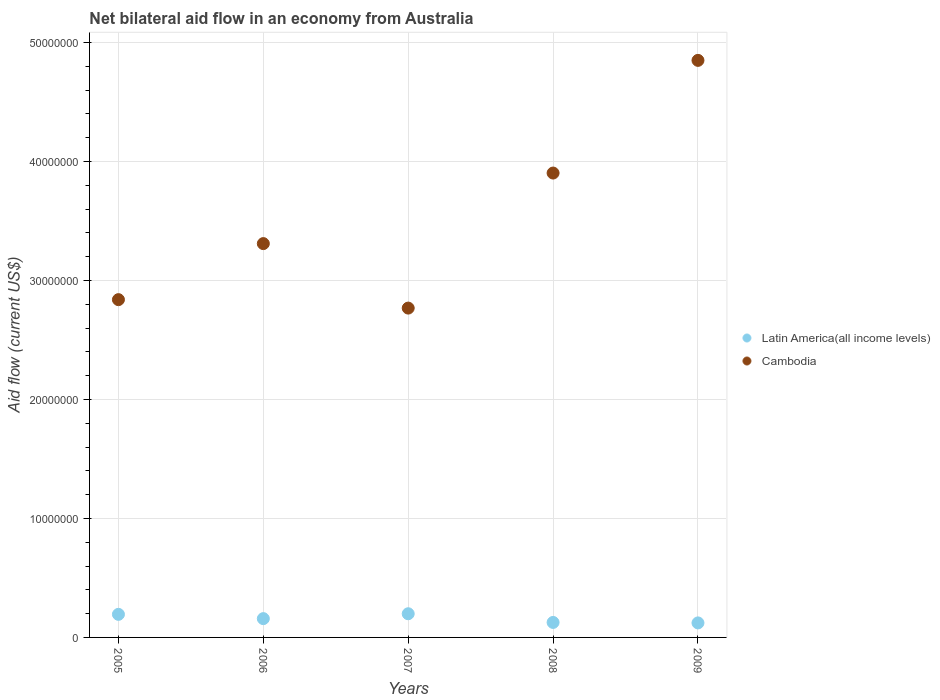What is the net bilateral aid flow in Cambodia in 2007?
Your response must be concise. 2.77e+07. Across all years, what is the maximum net bilateral aid flow in Cambodia?
Give a very brief answer. 4.85e+07. Across all years, what is the minimum net bilateral aid flow in Cambodia?
Provide a succinct answer. 2.77e+07. What is the total net bilateral aid flow in Cambodia in the graph?
Give a very brief answer. 1.77e+08. What is the difference between the net bilateral aid flow in Latin America(all income levels) in 2005 and that in 2006?
Offer a terse response. 3.60e+05. What is the difference between the net bilateral aid flow in Cambodia in 2006 and the net bilateral aid flow in Latin America(all income levels) in 2009?
Your answer should be very brief. 3.19e+07. What is the average net bilateral aid flow in Latin America(all income levels) per year?
Offer a very short reply. 1.60e+06. In the year 2009, what is the difference between the net bilateral aid flow in Latin America(all income levels) and net bilateral aid flow in Cambodia?
Provide a succinct answer. -4.73e+07. In how many years, is the net bilateral aid flow in Latin America(all income levels) greater than 2000000 US$?
Offer a very short reply. 0. What is the ratio of the net bilateral aid flow in Cambodia in 2006 to that in 2007?
Offer a terse response. 1.2. Is the net bilateral aid flow in Cambodia in 2005 less than that in 2009?
Give a very brief answer. Yes. What is the difference between the highest and the second highest net bilateral aid flow in Cambodia?
Offer a terse response. 9.47e+06. What is the difference between the highest and the lowest net bilateral aid flow in Cambodia?
Keep it short and to the point. 2.08e+07. In how many years, is the net bilateral aid flow in Latin America(all income levels) greater than the average net bilateral aid flow in Latin America(all income levels) taken over all years?
Your answer should be very brief. 2. Is the sum of the net bilateral aid flow in Latin America(all income levels) in 2006 and 2008 greater than the maximum net bilateral aid flow in Cambodia across all years?
Your response must be concise. No. Does the net bilateral aid flow in Cambodia monotonically increase over the years?
Give a very brief answer. No. How many dotlines are there?
Provide a succinct answer. 2. Are the values on the major ticks of Y-axis written in scientific E-notation?
Ensure brevity in your answer.  No. Where does the legend appear in the graph?
Ensure brevity in your answer.  Center right. How are the legend labels stacked?
Provide a succinct answer. Vertical. What is the title of the graph?
Offer a terse response. Net bilateral aid flow in an economy from Australia. What is the label or title of the X-axis?
Give a very brief answer. Years. What is the Aid flow (current US$) in Latin America(all income levels) in 2005?
Offer a very short reply. 1.94e+06. What is the Aid flow (current US$) of Cambodia in 2005?
Your answer should be very brief. 2.84e+07. What is the Aid flow (current US$) of Latin America(all income levels) in 2006?
Your response must be concise. 1.58e+06. What is the Aid flow (current US$) in Cambodia in 2006?
Provide a succinct answer. 3.31e+07. What is the Aid flow (current US$) of Latin America(all income levels) in 2007?
Provide a short and direct response. 1.99e+06. What is the Aid flow (current US$) in Cambodia in 2007?
Keep it short and to the point. 2.77e+07. What is the Aid flow (current US$) in Latin America(all income levels) in 2008?
Your answer should be compact. 1.26e+06. What is the Aid flow (current US$) of Cambodia in 2008?
Offer a terse response. 3.90e+07. What is the Aid flow (current US$) of Latin America(all income levels) in 2009?
Provide a succinct answer. 1.22e+06. What is the Aid flow (current US$) of Cambodia in 2009?
Make the answer very short. 4.85e+07. Across all years, what is the maximum Aid flow (current US$) of Latin America(all income levels)?
Your answer should be compact. 1.99e+06. Across all years, what is the maximum Aid flow (current US$) in Cambodia?
Make the answer very short. 4.85e+07. Across all years, what is the minimum Aid flow (current US$) of Latin America(all income levels)?
Give a very brief answer. 1.22e+06. Across all years, what is the minimum Aid flow (current US$) in Cambodia?
Make the answer very short. 2.77e+07. What is the total Aid flow (current US$) of Latin America(all income levels) in the graph?
Provide a succinct answer. 7.99e+06. What is the total Aid flow (current US$) of Cambodia in the graph?
Offer a very short reply. 1.77e+08. What is the difference between the Aid flow (current US$) in Latin America(all income levels) in 2005 and that in 2006?
Your response must be concise. 3.60e+05. What is the difference between the Aid flow (current US$) in Cambodia in 2005 and that in 2006?
Offer a terse response. -4.71e+06. What is the difference between the Aid flow (current US$) in Cambodia in 2005 and that in 2007?
Your answer should be very brief. 7.10e+05. What is the difference between the Aid flow (current US$) of Latin America(all income levels) in 2005 and that in 2008?
Offer a very short reply. 6.80e+05. What is the difference between the Aid flow (current US$) in Cambodia in 2005 and that in 2008?
Make the answer very short. -1.06e+07. What is the difference between the Aid flow (current US$) of Latin America(all income levels) in 2005 and that in 2009?
Give a very brief answer. 7.20e+05. What is the difference between the Aid flow (current US$) of Cambodia in 2005 and that in 2009?
Ensure brevity in your answer.  -2.01e+07. What is the difference between the Aid flow (current US$) of Latin America(all income levels) in 2006 and that in 2007?
Your answer should be compact. -4.10e+05. What is the difference between the Aid flow (current US$) of Cambodia in 2006 and that in 2007?
Your answer should be very brief. 5.42e+06. What is the difference between the Aid flow (current US$) in Latin America(all income levels) in 2006 and that in 2008?
Provide a succinct answer. 3.20e+05. What is the difference between the Aid flow (current US$) in Cambodia in 2006 and that in 2008?
Make the answer very short. -5.93e+06. What is the difference between the Aid flow (current US$) in Cambodia in 2006 and that in 2009?
Provide a short and direct response. -1.54e+07. What is the difference between the Aid flow (current US$) of Latin America(all income levels) in 2007 and that in 2008?
Ensure brevity in your answer.  7.30e+05. What is the difference between the Aid flow (current US$) in Cambodia in 2007 and that in 2008?
Make the answer very short. -1.14e+07. What is the difference between the Aid flow (current US$) of Latin America(all income levels) in 2007 and that in 2009?
Provide a short and direct response. 7.70e+05. What is the difference between the Aid flow (current US$) in Cambodia in 2007 and that in 2009?
Your answer should be very brief. -2.08e+07. What is the difference between the Aid flow (current US$) in Cambodia in 2008 and that in 2009?
Provide a succinct answer. -9.47e+06. What is the difference between the Aid flow (current US$) of Latin America(all income levels) in 2005 and the Aid flow (current US$) of Cambodia in 2006?
Provide a succinct answer. -3.12e+07. What is the difference between the Aid flow (current US$) of Latin America(all income levels) in 2005 and the Aid flow (current US$) of Cambodia in 2007?
Offer a very short reply. -2.57e+07. What is the difference between the Aid flow (current US$) of Latin America(all income levels) in 2005 and the Aid flow (current US$) of Cambodia in 2008?
Provide a succinct answer. -3.71e+07. What is the difference between the Aid flow (current US$) of Latin America(all income levels) in 2005 and the Aid flow (current US$) of Cambodia in 2009?
Offer a very short reply. -4.66e+07. What is the difference between the Aid flow (current US$) in Latin America(all income levels) in 2006 and the Aid flow (current US$) in Cambodia in 2007?
Offer a very short reply. -2.61e+07. What is the difference between the Aid flow (current US$) of Latin America(all income levels) in 2006 and the Aid flow (current US$) of Cambodia in 2008?
Your answer should be compact. -3.74e+07. What is the difference between the Aid flow (current US$) of Latin America(all income levels) in 2006 and the Aid flow (current US$) of Cambodia in 2009?
Offer a terse response. -4.69e+07. What is the difference between the Aid flow (current US$) in Latin America(all income levels) in 2007 and the Aid flow (current US$) in Cambodia in 2008?
Your answer should be compact. -3.70e+07. What is the difference between the Aid flow (current US$) of Latin America(all income levels) in 2007 and the Aid flow (current US$) of Cambodia in 2009?
Give a very brief answer. -4.65e+07. What is the difference between the Aid flow (current US$) in Latin America(all income levels) in 2008 and the Aid flow (current US$) in Cambodia in 2009?
Give a very brief answer. -4.72e+07. What is the average Aid flow (current US$) of Latin America(all income levels) per year?
Ensure brevity in your answer.  1.60e+06. What is the average Aid flow (current US$) in Cambodia per year?
Offer a very short reply. 3.53e+07. In the year 2005, what is the difference between the Aid flow (current US$) of Latin America(all income levels) and Aid flow (current US$) of Cambodia?
Give a very brief answer. -2.64e+07. In the year 2006, what is the difference between the Aid flow (current US$) in Latin America(all income levels) and Aid flow (current US$) in Cambodia?
Your answer should be compact. -3.15e+07. In the year 2007, what is the difference between the Aid flow (current US$) in Latin America(all income levels) and Aid flow (current US$) in Cambodia?
Give a very brief answer. -2.57e+07. In the year 2008, what is the difference between the Aid flow (current US$) in Latin America(all income levels) and Aid flow (current US$) in Cambodia?
Make the answer very short. -3.78e+07. In the year 2009, what is the difference between the Aid flow (current US$) in Latin America(all income levels) and Aid flow (current US$) in Cambodia?
Ensure brevity in your answer.  -4.73e+07. What is the ratio of the Aid flow (current US$) in Latin America(all income levels) in 2005 to that in 2006?
Provide a succinct answer. 1.23. What is the ratio of the Aid flow (current US$) in Cambodia in 2005 to that in 2006?
Offer a very short reply. 0.86. What is the ratio of the Aid flow (current US$) of Latin America(all income levels) in 2005 to that in 2007?
Provide a succinct answer. 0.97. What is the ratio of the Aid flow (current US$) of Cambodia in 2005 to that in 2007?
Your answer should be very brief. 1.03. What is the ratio of the Aid flow (current US$) of Latin America(all income levels) in 2005 to that in 2008?
Keep it short and to the point. 1.54. What is the ratio of the Aid flow (current US$) in Cambodia in 2005 to that in 2008?
Offer a very short reply. 0.73. What is the ratio of the Aid flow (current US$) in Latin America(all income levels) in 2005 to that in 2009?
Ensure brevity in your answer.  1.59. What is the ratio of the Aid flow (current US$) of Cambodia in 2005 to that in 2009?
Keep it short and to the point. 0.59. What is the ratio of the Aid flow (current US$) of Latin America(all income levels) in 2006 to that in 2007?
Your answer should be compact. 0.79. What is the ratio of the Aid flow (current US$) of Cambodia in 2006 to that in 2007?
Offer a very short reply. 1.2. What is the ratio of the Aid flow (current US$) of Latin America(all income levels) in 2006 to that in 2008?
Provide a short and direct response. 1.25. What is the ratio of the Aid flow (current US$) of Cambodia in 2006 to that in 2008?
Your answer should be very brief. 0.85. What is the ratio of the Aid flow (current US$) in Latin America(all income levels) in 2006 to that in 2009?
Provide a short and direct response. 1.3. What is the ratio of the Aid flow (current US$) of Cambodia in 2006 to that in 2009?
Your answer should be very brief. 0.68. What is the ratio of the Aid flow (current US$) in Latin America(all income levels) in 2007 to that in 2008?
Keep it short and to the point. 1.58. What is the ratio of the Aid flow (current US$) in Cambodia in 2007 to that in 2008?
Ensure brevity in your answer.  0.71. What is the ratio of the Aid flow (current US$) in Latin America(all income levels) in 2007 to that in 2009?
Keep it short and to the point. 1.63. What is the ratio of the Aid flow (current US$) of Cambodia in 2007 to that in 2009?
Your answer should be compact. 0.57. What is the ratio of the Aid flow (current US$) in Latin America(all income levels) in 2008 to that in 2009?
Provide a short and direct response. 1.03. What is the ratio of the Aid flow (current US$) in Cambodia in 2008 to that in 2009?
Offer a terse response. 0.8. What is the difference between the highest and the second highest Aid flow (current US$) of Latin America(all income levels)?
Offer a terse response. 5.00e+04. What is the difference between the highest and the second highest Aid flow (current US$) of Cambodia?
Offer a terse response. 9.47e+06. What is the difference between the highest and the lowest Aid flow (current US$) of Latin America(all income levels)?
Offer a terse response. 7.70e+05. What is the difference between the highest and the lowest Aid flow (current US$) in Cambodia?
Your answer should be very brief. 2.08e+07. 